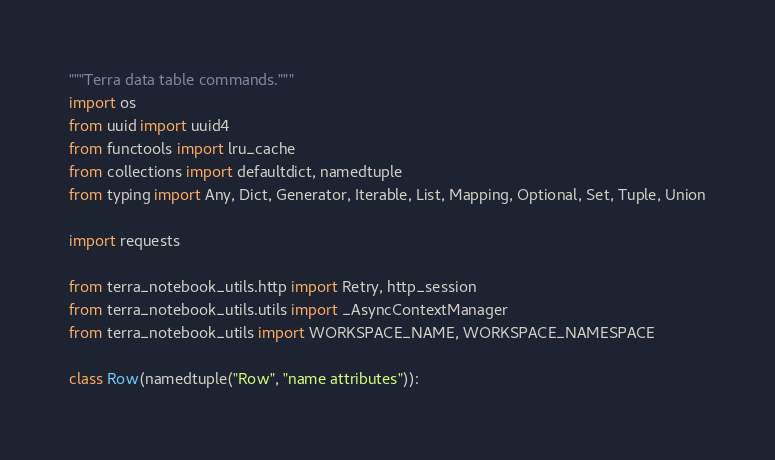Convert code to text. <code><loc_0><loc_0><loc_500><loc_500><_Python_>"""Terra data table commands."""
import os
from uuid import uuid4
from functools import lru_cache
from collections import defaultdict, namedtuple
from typing import Any, Dict, Generator, Iterable, List, Mapping, Optional, Set, Tuple, Union

import requests

from terra_notebook_utils.http import Retry, http_session
from terra_notebook_utils.utils import _AsyncContextManager
from terra_notebook_utils import WORKSPACE_NAME, WORKSPACE_NAMESPACE

class Row(namedtuple("Row", "name attributes")):</code> 